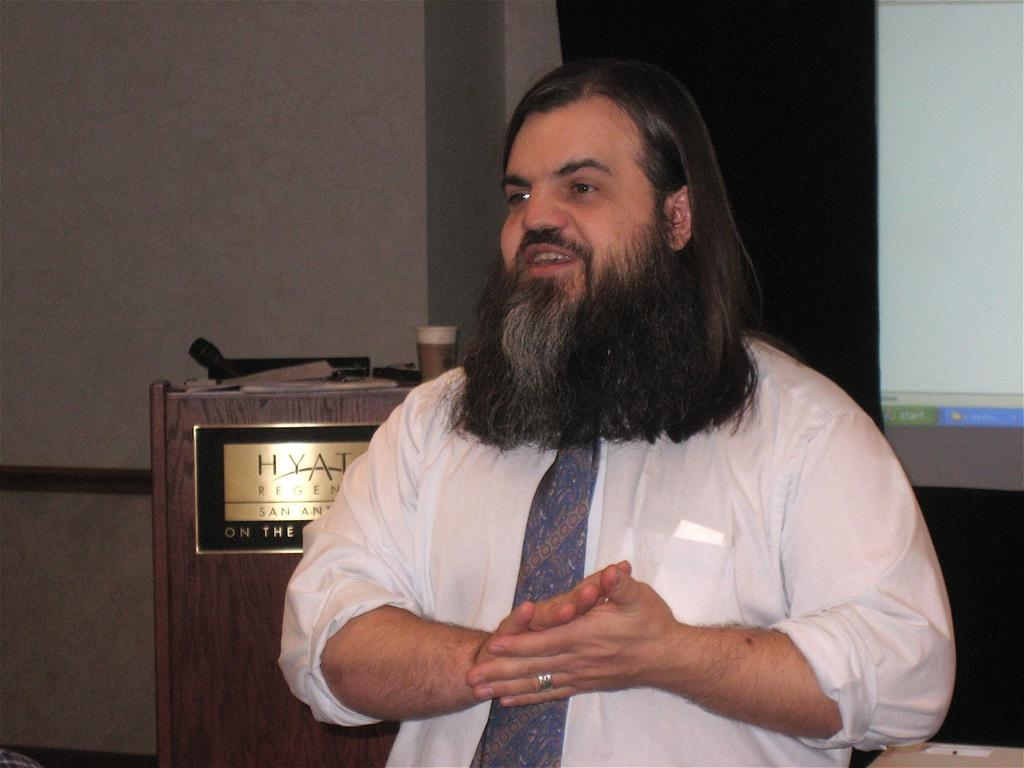What is the main subject of the image? There is a person in the image. Can you describe the person's appearance? The person is wearing a white dress and has a long beard. What can be seen in the right corner of the image? There is a projected image in the right corner of the image. What else is visible in the background of the image? There are other objects in the background of the image. What type of cabbage is being used for the person to talk to in the image? There is no cabbage present in the image, nor is there any indication that the person is talking to anything. Can you see a bat flying in the background of the image? There is no bat visible in the background of the image. 